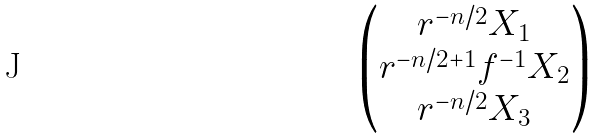<formula> <loc_0><loc_0><loc_500><loc_500>\begin{pmatrix} r ^ { - n / 2 } X _ { 1 } \\ r ^ { - n / 2 + 1 } f ^ { - 1 } X _ { 2 } \\ r ^ { - n / 2 } X _ { 3 } \end{pmatrix}</formula> 